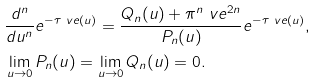<formula> <loc_0><loc_0><loc_500><loc_500>& \frac { d ^ { n } } { d u ^ { n } } e ^ { - \tau _ { \ } v e ( u ) } = \frac { Q _ { n } ( u ) + \pi ^ { n } \ v e ^ { 2 n } } { P _ { n } ( u ) } e ^ { - \tau _ { \ } v e ( u ) } , \\ & \lim _ { u \to 0 } P _ { n } ( u ) = \lim _ { u \to 0 } Q _ { n } ( u ) = 0 .</formula> 